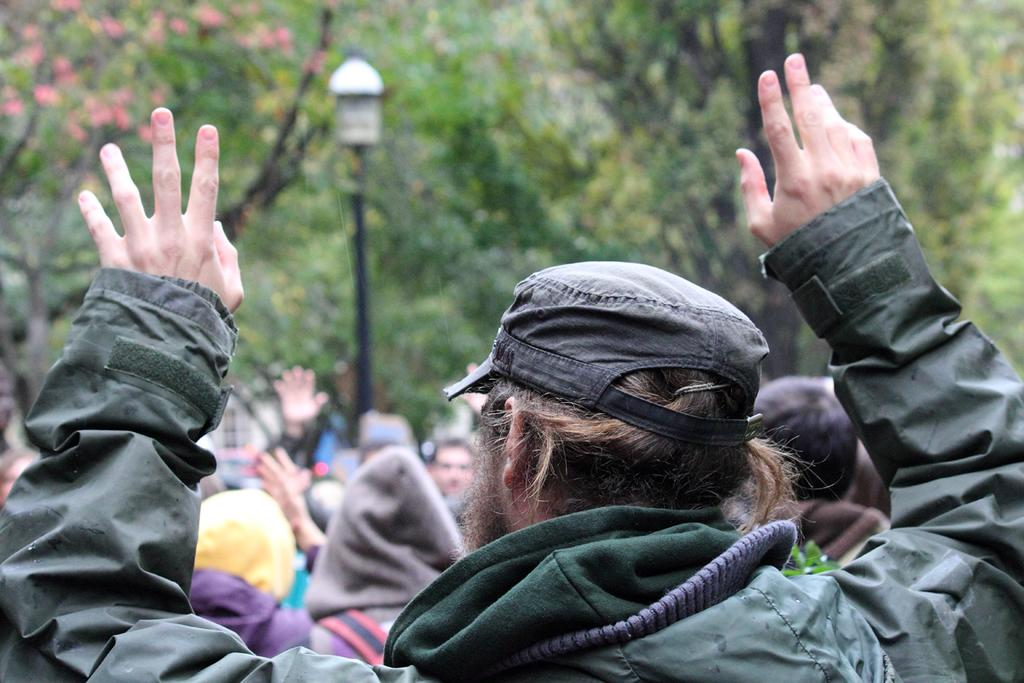How many people are in the image? There are people in the image, but the exact number is not specified. Can you describe the clothing of one of the people? Yes, there is a person wearing a green jacket. What type of structure can be seen in the image? There is a light pole in the image. What type of vegetation is present in the image? There are trees in the image. Can you tell me how many fish are swimming in the image? There are no fish present in the image. Is there any credit card information visible in the image? There is no credit card information visible in the image. 